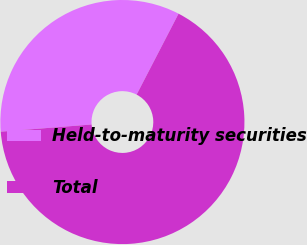Convert chart to OTSL. <chart><loc_0><loc_0><loc_500><loc_500><pie_chart><fcel>Held-to-maturity securities<fcel>Total<nl><fcel>33.87%<fcel>66.13%<nl></chart> 